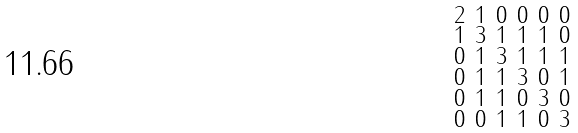Convert formula to latex. <formula><loc_0><loc_0><loc_500><loc_500>\begin{smallmatrix} 2 & 1 & 0 & 0 & 0 & 0 \\ 1 & 3 & 1 & 1 & 1 & 0 \\ 0 & 1 & 3 & 1 & 1 & 1 \\ 0 & 1 & 1 & 3 & 0 & 1 \\ 0 & 1 & 1 & 0 & 3 & 0 \\ 0 & 0 & 1 & 1 & 0 & 3 \end{smallmatrix}</formula> 